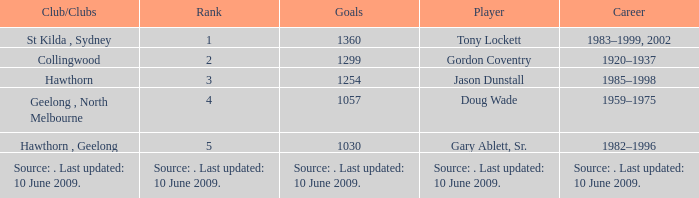Which player has 1299 goals? Gordon Coventry. 